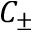<formula> <loc_0><loc_0><loc_500><loc_500>C _ { \pm }</formula> 